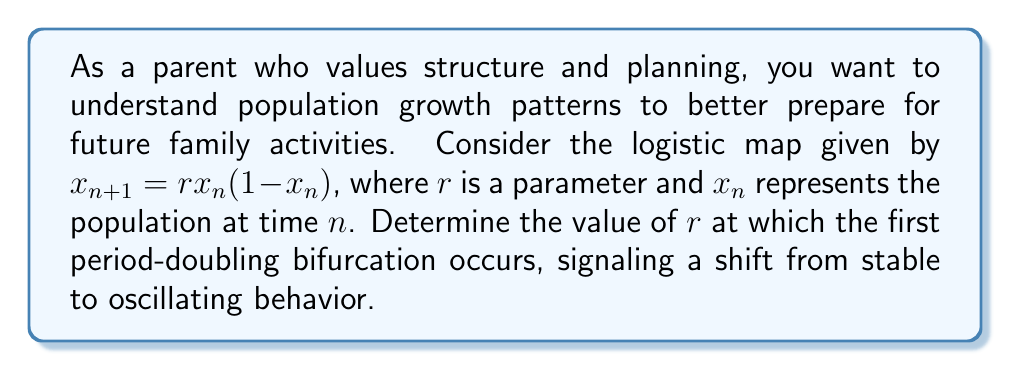Show me your answer to this math problem. Let's approach this step-by-step:

1) The logistic map is given by $x_{n+1} = rx_n(1-x_n)$.

2) For small values of $r$, the system has a stable fixed point. We need to find when this stability changes.

3) To find fixed points, we set $x_{n+1} = x_n = x^*$:

   $x^* = rx^*(1-x^*)$

4) Solving this equation:
   
   $x^* = 0$ or $x^* = 1 - \frac{1}{r}$

5) The non-zero fixed point $x^* = 1 - \frac{1}{r}$ is of interest.

6) To determine stability, we calculate the derivative of the map at this fixed point:

   $f'(x) = r(1-2x)$
   
   $f'(x^*) = r(1-2(1-\frac{1}{r})) = r(1-2+\frac{2}{r}) = 2-r$

7) The fixed point loses stability when $|f'(x^*)| = 1$. In this case, when $f'(x^*) = -1$:

   $2-r = -1$
   $r = 3$

8) At $r = 3$, the system undergoes its first period-doubling bifurcation, transitioning from a stable fixed point to an oscillation between two values.
Answer: $r = 3$ 